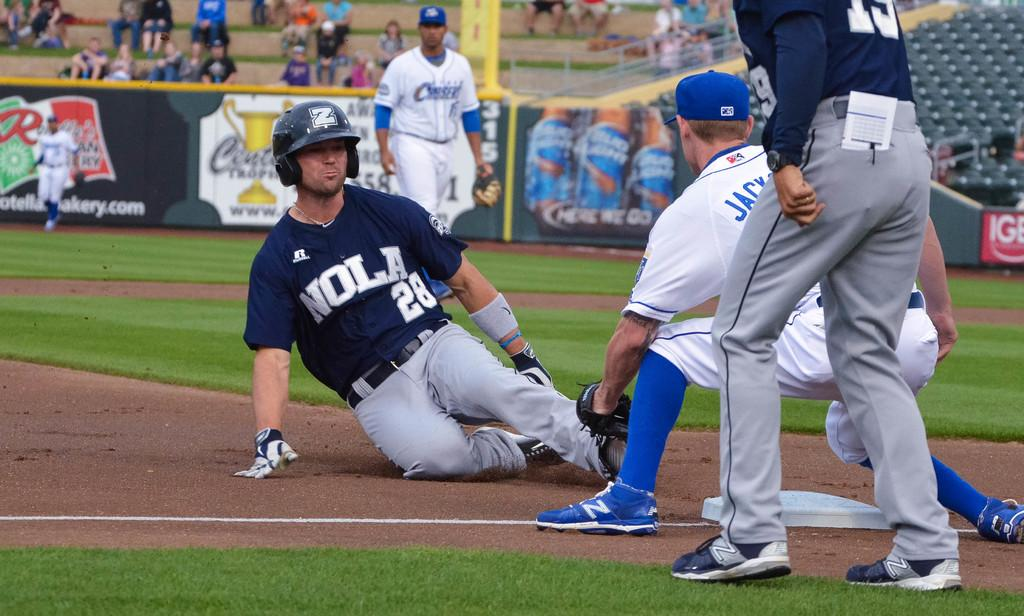<image>
Offer a succinct explanation of the picture presented. A baseball games with player 28 sliding into a base. 